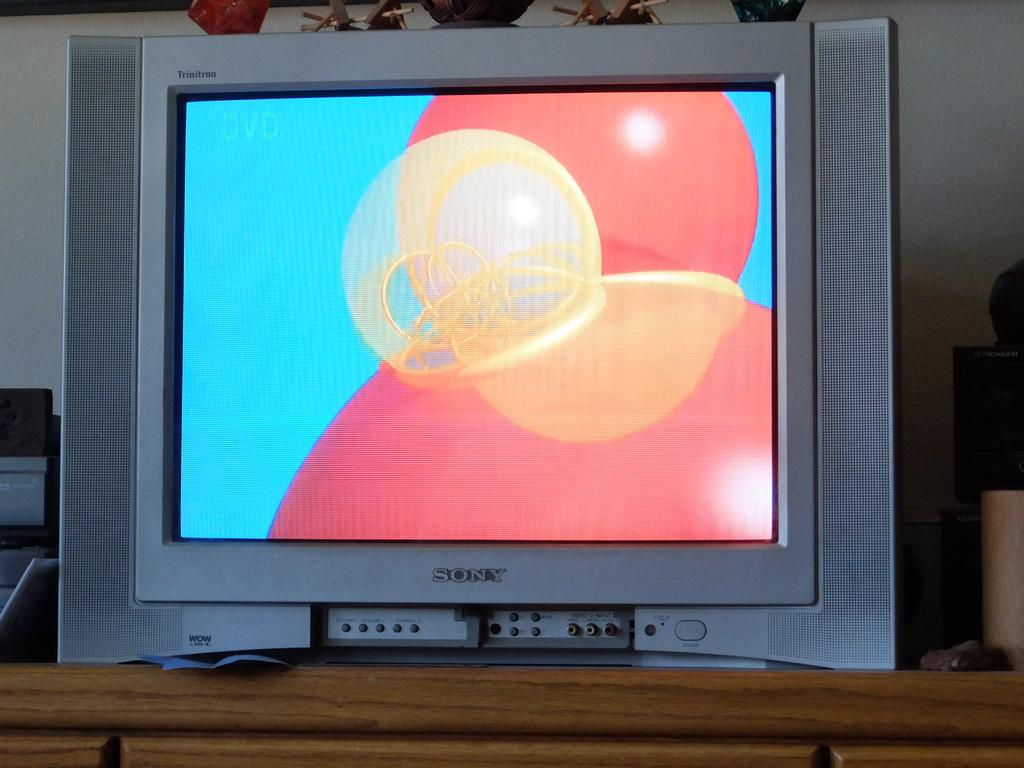<image>
Describe the image concisely. A Sony television screen with red and orange circles and a blue background on it. 